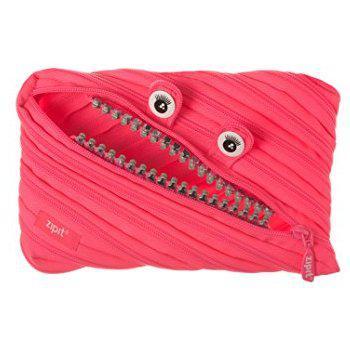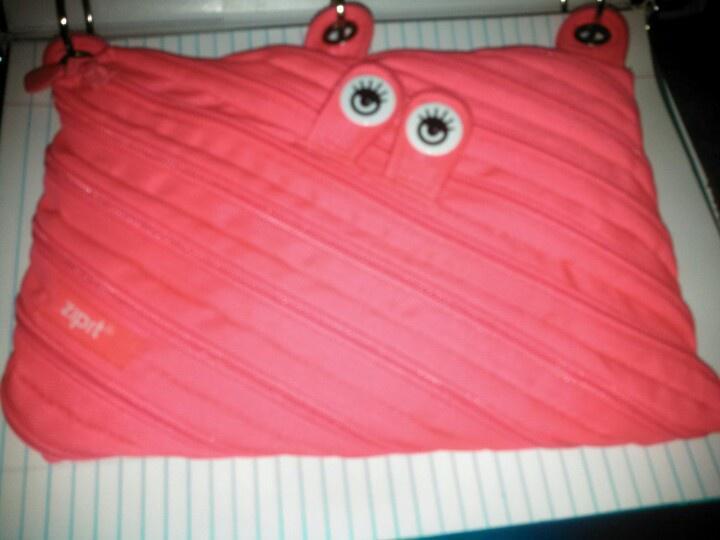The first image is the image on the left, the second image is the image on the right. Examine the images to the left and right. Is the description "An image shows two closed fabric cases, one pink and one blue." accurate? Answer yes or no. No. The first image is the image on the left, the second image is the image on the right. Evaluate the accuracy of this statement regarding the images: "Every pouch has eyes.". Is it true? Answer yes or no. Yes. 